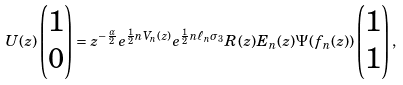<formula> <loc_0><loc_0><loc_500><loc_500>U ( z ) \begin{pmatrix} 1 \\ 0 \end{pmatrix} = z ^ { - \frac { \alpha } { 2 } } e ^ { \frac { 1 } { 2 } n V _ { n } ( z ) } e ^ { \frac { 1 } { 2 } n \ell _ { n } \sigma _ { 3 } } R ( z ) E _ { n } ( z ) \Psi ( f _ { n } ( z ) ) \begin{pmatrix} 1 \\ 1 \end{pmatrix} ,</formula> 